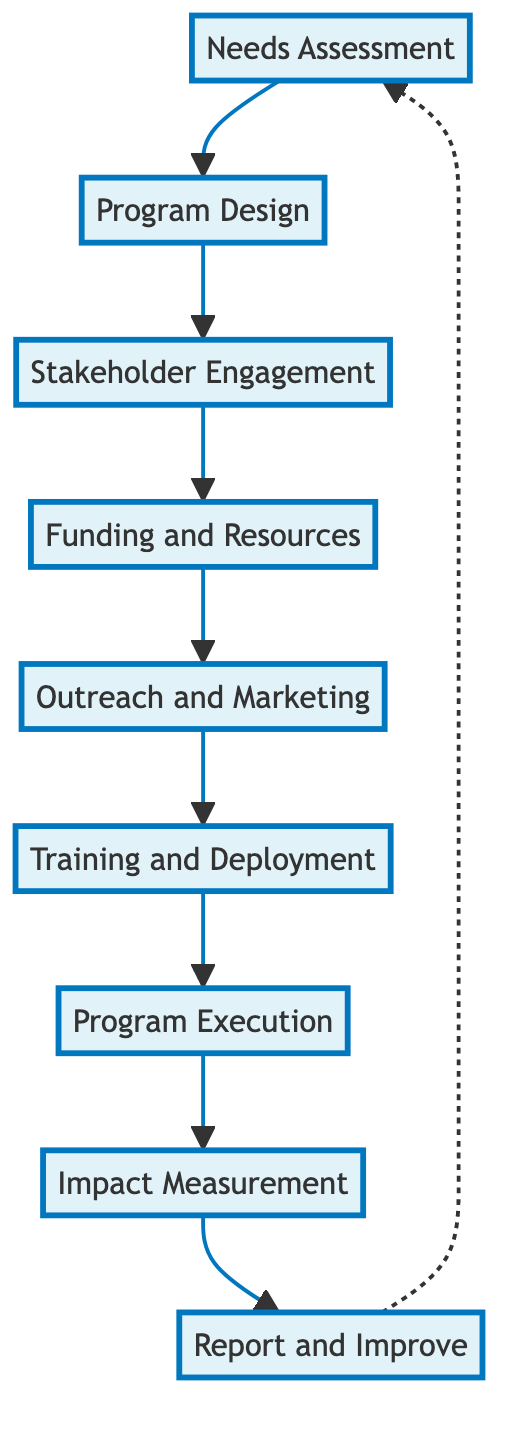What is the first step in the program's flow? The diagram indicates that "Needs Assessment" is the starting point of the process, as it is the first element connected in the flowchart.
Answer: Needs Assessment How many total elements are represented in the diagram? There are nine distinct elements listed in the diagram, each connected sequentially.
Answer: Nine Which step comes directly after "Stakeholder Engagement"? The diagram shows that "Funding and Resources" follows "Stakeholder Engagement" in the sequence of steps.
Answer: Funding and Resources What is the last step in the outreach program? The flowchart indicates that "Report and Improve" is the final step in the process, showing that this is where outcomes are reviewed and improvements are suggested.
Answer: Report and Improve Which two steps are related through stakeholder support and advocacy? The connection between "Stakeholder Engagement" and "Funding and Resources" highlights the involvement of community leaders and organizations to secure resources.
Answer: Stakeholder Engagement and Funding and Resources What is the feedback mechanism used for impact measurement? The diagram specifies that feedback is collected through forms, interviews, and follow-ups, allowing for a comprehensive analysis of the program's effectiveness.
Answer: Feedback forms, interviews, and case follow-ups Identify a key partnership resource mentioned in the program design phase. The diagram outlines that partnerships with law schools, legal clinics, and NGOs are crucial during the Program Design phase for curriculum development.
Answer: Law schools, legal clinics, and NGOs Which node is connected back to the "Needs Assessment"? The diagram shows an indirect connection reflecting a feedback loop, where "Report and Improve" relates back to "Needs Assessment" for continuous evaluation and adaptation.
Answer: Report and Improve What role do community centers and churches play in the outreach program? According to the Outreach and Marketing phase, community centers and churches are highlighted as destinations for collaboration to promote the program.
Answer: Collaboration in promotion 